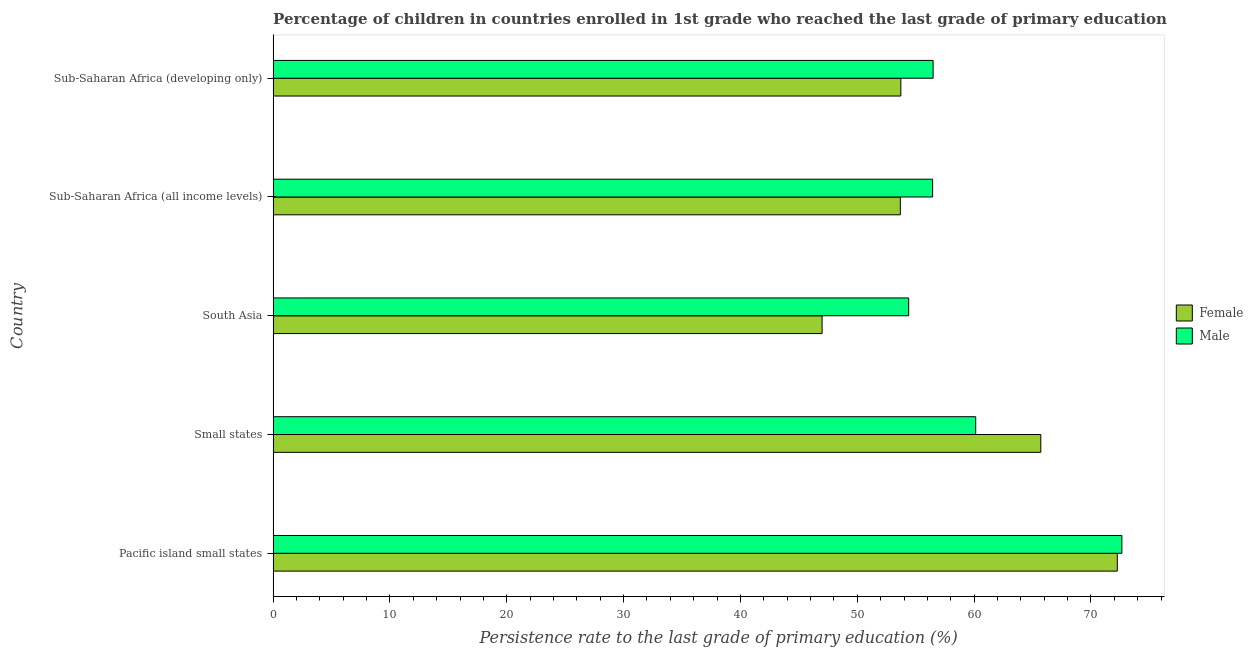How many different coloured bars are there?
Give a very brief answer. 2. Are the number of bars on each tick of the Y-axis equal?
Your response must be concise. Yes. How many bars are there on the 4th tick from the top?
Provide a succinct answer. 2. How many bars are there on the 2nd tick from the bottom?
Give a very brief answer. 2. What is the label of the 1st group of bars from the top?
Your answer should be very brief. Sub-Saharan Africa (developing only). What is the persistence rate of female students in Sub-Saharan Africa (all income levels)?
Make the answer very short. 53.69. Across all countries, what is the maximum persistence rate of female students?
Give a very brief answer. 72.26. Across all countries, what is the minimum persistence rate of male students?
Your response must be concise. 54.4. In which country was the persistence rate of male students maximum?
Offer a very short reply. Pacific island small states. In which country was the persistence rate of female students minimum?
Provide a succinct answer. South Asia. What is the total persistence rate of male students in the graph?
Your answer should be compact. 300.13. What is the difference between the persistence rate of male students in Pacific island small states and that in Sub-Saharan Africa (developing only)?
Ensure brevity in your answer.  16.16. What is the difference between the persistence rate of female students in Sub-Saharan Africa (all income levels) and the persistence rate of male students in Sub-Saharan Africa (developing only)?
Give a very brief answer. -2.81. What is the average persistence rate of female students per country?
Offer a very short reply. 58.48. What is the difference between the persistence rate of female students and persistence rate of male students in Pacific island small states?
Provide a succinct answer. -0.39. Is the persistence rate of female students in Small states less than that in South Asia?
Give a very brief answer. No. Is the difference between the persistence rate of female students in Sub-Saharan Africa (all income levels) and Sub-Saharan Africa (developing only) greater than the difference between the persistence rate of male students in Sub-Saharan Africa (all income levels) and Sub-Saharan Africa (developing only)?
Offer a very short reply. No. What is the difference between the highest and the second highest persistence rate of male students?
Your response must be concise. 12.51. What is the difference between the highest and the lowest persistence rate of female students?
Give a very brief answer. 25.27. Is the sum of the persistence rate of female students in Small states and South Asia greater than the maximum persistence rate of male students across all countries?
Keep it short and to the point. Yes. How many bars are there?
Give a very brief answer. 10. Are all the bars in the graph horizontal?
Offer a terse response. Yes. How many countries are there in the graph?
Offer a terse response. 5. Are the values on the major ticks of X-axis written in scientific E-notation?
Your response must be concise. No. Does the graph contain grids?
Keep it short and to the point. No. How many legend labels are there?
Give a very brief answer. 2. How are the legend labels stacked?
Make the answer very short. Vertical. What is the title of the graph?
Provide a succinct answer. Percentage of children in countries enrolled in 1st grade who reached the last grade of primary education. Does "Total Population" appear as one of the legend labels in the graph?
Offer a very short reply. No. What is the label or title of the X-axis?
Make the answer very short. Persistence rate to the last grade of primary education (%). What is the Persistence rate to the last grade of primary education (%) in Female in Pacific island small states?
Provide a succinct answer. 72.26. What is the Persistence rate to the last grade of primary education (%) in Male in Pacific island small states?
Give a very brief answer. 72.65. What is the Persistence rate to the last grade of primary education (%) of Female in Small states?
Make the answer very short. 65.71. What is the Persistence rate to the last grade of primary education (%) of Male in Small states?
Give a very brief answer. 60.14. What is the Persistence rate to the last grade of primary education (%) of Female in South Asia?
Your response must be concise. 46.99. What is the Persistence rate to the last grade of primary education (%) in Male in South Asia?
Offer a terse response. 54.4. What is the Persistence rate to the last grade of primary education (%) of Female in Sub-Saharan Africa (all income levels)?
Provide a succinct answer. 53.69. What is the Persistence rate to the last grade of primary education (%) in Male in Sub-Saharan Africa (all income levels)?
Keep it short and to the point. 56.45. What is the Persistence rate to the last grade of primary education (%) of Female in Sub-Saharan Africa (developing only)?
Offer a terse response. 53.73. What is the Persistence rate to the last grade of primary education (%) of Male in Sub-Saharan Africa (developing only)?
Your answer should be compact. 56.49. Across all countries, what is the maximum Persistence rate to the last grade of primary education (%) in Female?
Offer a very short reply. 72.26. Across all countries, what is the maximum Persistence rate to the last grade of primary education (%) of Male?
Provide a short and direct response. 72.65. Across all countries, what is the minimum Persistence rate to the last grade of primary education (%) of Female?
Offer a terse response. 46.99. Across all countries, what is the minimum Persistence rate to the last grade of primary education (%) in Male?
Give a very brief answer. 54.4. What is the total Persistence rate to the last grade of primary education (%) of Female in the graph?
Your response must be concise. 292.38. What is the total Persistence rate to the last grade of primary education (%) in Male in the graph?
Provide a succinct answer. 300.13. What is the difference between the Persistence rate to the last grade of primary education (%) in Female in Pacific island small states and that in Small states?
Your answer should be very brief. 6.55. What is the difference between the Persistence rate to the last grade of primary education (%) of Male in Pacific island small states and that in Small states?
Your answer should be very brief. 12.51. What is the difference between the Persistence rate to the last grade of primary education (%) in Female in Pacific island small states and that in South Asia?
Make the answer very short. 25.27. What is the difference between the Persistence rate to the last grade of primary education (%) in Male in Pacific island small states and that in South Asia?
Offer a very short reply. 18.25. What is the difference between the Persistence rate to the last grade of primary education (%) in Female in Pacific island small states and that in Sub-Saharan Africa (all income levels)?
Ensure brevity in your answer.  18.57. What is the difference between the Persistence rate to the last grade of primary education (%) of Male in Pacific island small states and that in Sub-Saharan Africa (all income levels)?
Your answer should be compact. 16.2. What is the difference between the Persistence rate to the last grade of primary education (%) of Female in Pacific island small states and that in Sub-Saharan Africa (developing only)?
Offer a very short reply. 18.53. What is the difference between the Persistence rate to the last grade of primary education (%) in Male in Pacific island small states and that in Sub-Saharan Africa (developing only)?
Ensure brevity in your answer.  16.16. What is the difference between the Persistence rate to the last grade of primary education (%) in Female in Small states and that in South Asia?
Your answer should be compact. 18.72. What is the difference between the Persistence rate to the last grade of primary education (%) in Male in Small states and that in South Asia?
Provide a short and direct response. 5.74. What is the difference between the Persistence rate to the last grade of primary education (%) of Female in Small states and that in Sub-Saharan Africa (all income levels)?
Provide a short and direct response. 12.02. What is the difference between the Persistence rate to the last grade of primary education (%) in Male in Small states and that in Sub-Saharan Africa (all income levels)?
Your answer should be very brief. 3.69. What is the difference between the Persistence rate to the last grade of primary education (%) in Female in Small states and that in Sub-Saharan Africa (developing only)?
Keep it short and to the point. 11.98. What is the difference between the Persistence rate to the last grade of primary education (%) in Male in Small states and that in Sub-Saharan Africa (developing only)?
Offer a terse response. 3.64. What is the difference between the Persistence rate to the last grade of primary education (%) in Female in South Asia and that in Sub-Saharan Africa (all income levels)?
Your answer should be very brief. -6.7. What is the difference between the Persistence rate to the last grade of primary education (%) of Male in South Asia and that in Sub-Saharan Africa (all income levels)?
Make the answer very short. -2.05. What is the difference between the Persistence rate to the last grade of primary education (%) in Female in South Asia and that in Sub-Saharan Africa (developing only)?
Offer a terse response. -6.74. What is the difference between the Persistence rate to the last grade of primary education (%) of Male in South Asia and that in Sub-Saharan Africa (developing only)?
Make the answer very short. -2.09. What is the difference between the Persistence rate to the last grade of primary education (%) in Female in Sub-Saharan Africa (all income levels) and that in Sub-Saharan Africa (developing only)?
Offer a terse response. -0.05. What is the difference between the Persistence rate to the last grade of primary education (%) in Male in Sub-Saharan Africa (all income levels) and that in Sub-Saharan Africa (developing only)?
Offer a very short reply. -0.04. What is the difference between the Persistence rate to the last grade of primary education (%) of Female in Pacific island small states and the Persistence rate to the last grade of primary education (%) of Male in Small states?
Your answer should be very brief. 12.12. What is the difference between the Persistence rate to the last grade of primary education (%) in Female in Pacific island small states and the Persistence rate to the last grade of primary education (%) in Male in South Asia?
Keep it short and to the point. 17.86. What is the difference between the Persistence rate to the last grade of primary education (%) of Female in Pacific island small states and the Persistence rate to the last grade of primary education (%) of Male in Sub-Saharan Africa (all income levels)?
Keep it short and to the point. 15.81. What is the difference between the Persistence rate to the last grade of primary education (%) in Female in Pacific island small states and the Persistence rate to the last grade of primary education (%) in Male in Sub-Saharan Africa (developing only)?
Make the answer very short. 15.76. What is the difference between the Persistence rate to the last grade of primary education (%) of Female in Small states and the Persistence rate to the last grade of primary education (%) of Male in South Asia?
Give a very brief answer. 11.31. What is the difference between the Persistence rate to the last grade of primary education (%) of Female in Small states and the Persistence rate to the last grade of primary education (%) of Male in Sub-Saharan Africa (all income levels)?
Make the answer very short. 9.26. What is the difference between the Persistence rate to the last grade of primary education (%) in Female in Small states and the Persistence rate to the last grade of primary education (%) in Male in Sub-Saharan Africa (developing only)?
Make the answer very short. 9.22. What is the difference between the Persistence rate to the last grade of primary education (%) in Female in South Asia and the Persistence rate to the last grade of primary education (%) in Male in Sub-Saharan Africa (all income levels)?
Offer a terse response. -9.46. What is the difference between the Persistence rate to the last grade of primary education (%) in Female in South Asia and the Persistence rate to the last grade of primary education (%) in Male in Sub-Saharan Africa (developing only)?
Your response must be concise. -9.5. What is the difference between the Persistence rate to the last grade of primary education (%) of Female in Sub-Saharan Africa (all income levels) and the Persistence rate to the last grade of primary education (%) of Male in Sub-Saharan Africa (developing only)?
Keep it short and to the point. -2.81. What is the average Persistence rate to the last grade of primary education (%) in Female per country?
Your answer should be compact. 58.48. What is the average Persistence rate to the last grade of primary education (%) of Male per country?
Your answer should be compact. 60.03. What is the difference between the Persistence rate to the last grade of primary education (%) in Female and Persistence rate to the last grade of primary education (%) in Male in Pacific island small states?
Your answer should be very brief. -0.39. What is the difference between the Persistence rate to the last grade of primary education (%) in Female and Persistence rate to the last grade of primary education (%) in Male in Small states?
Offer a terse response. 5.57. What is the difference between the Persistence rate to the last grade of primary education (%) in Female and Persistence rate to the last grade of primary education (%) in Male in South Asia?
Offer a terse response. -7.41. What is the difference between the Persistence rate to the last grade of primary education (%) of Female and Persistence rate to the last grade of primary education (%) of Male in Sub-Saharan Africa (all income levels)?
Provide a succinct answer. -2.76. What is the difference between the Persistence rate to the last grade of primary education (%) in Female and Persistence rate to the last grade of primary education (%) in Male in Sub-Saharan Africa (developing only)?
Give a very brief answer. -2.76. What is the ratio of the Persistence rate to the last grade of primary education (%) in Female in Pacific island small states to that in Small states?
Your answer should be very brief. 1.1. What is the ratio of the Persistence rate to the last grade of primary education (%) in Male in Pacific island small states to that in Small states?
Give a very brief answer. 1.21. What is the ratio of the Persistence rate to the last grade of primary education (%) in Female in Pacific island small states to that in South Asia?
Your response must be concise. 1.54. What is the ratio of the Persistence rate to the last grade of primary education (%) of Male in Pacific island small states to that in South Asia?
Offer a very short reply. 1.34. What is the ratio of the Persistence rate to the last grade of primary education (%) of Female in Pacific island small states to that in Sub-Saharan Africa (all income levels)?
Provide a short and direct response. 1.35. What is the ratio of the Persistence rate to the last grade of primary education (%) of Male in Pacific island small states to that in Sub-Saharan Africa (all income levels)?
Your response must be concise. 1.29. What is the ratio of the Persistence rate to the last grade of primary education (%) in Female in Pacific island small states to that in Sub-Saharan Africa (developing only)?
Provide a succinct answer. 1.34. What is the ratio of the Persistence rate to the last grade of primary education (%) of Male in Pacific island small states to that in Sub-Saharan Africa (developing only)?
Make the answer very short. 1.29. What is the ratio of the Persistence rate to the last grade of primary education (%) of Female in Small states to that in South Asia?
Keep it short and to the point. 1.4. What is the ratio of the Persistence rate to the last grade of primary education (%) of Male in Small states to that in South Asia?
Make the answer very short. 1.11. What is the ratio of the Persistence rate to the last grade of primary education (%) of Female in Small states to that in Sub-Saharan Africa (all income levels)?
Keep it short and to the point. 1.22. What is the ratio of the Persistence rate to the last grade of primary education (%) of Male in Small states to that in Sub-Saharan Africa (all income levels)?
Ensure brevity in your answer.  1.07. What is the ratio of the Persistence rate to the last grade of primary education (%) in Female in Small states to that in Sub-Saharan Africa (developing only)?
Your answer should be compact. 1.22. What is the ratio of the Persistence rate to the last grade of primary education (%) of Male in Small states to that in Sub-Saharan Africa (developing only)?
Provide a succinct answer. 1.06. What is the ratio of the Persistence rate to the last grade of primary education (%) in Female in South Asia to that in Sub-Saharan Africa (all income levels)?
Offer a very short reply. 0.88. What is the ratio of the Persistence rate to the last grade of primary education (%) of Male in South Asia to that in Sub-Saharan Africa (all income levels)?
Keep it short and to the point. 0.96. What is the ratio of the Persistence rate to the last grade of primary education (%) of Female in South Asia to that in Sub-Saharan Africa (developing only)?
Give a very brief answer. 0.87. What is the ratio of the Persistence rate to the last grade of primary education (%) of Male in South Asia to that in Sub-Saharan Africa (developing only)?
Offer a terse response. 0.96. What is the ratio of the Persistence rate to the last grade of primary education (%) in Female in Sub-Saharan Africa (all income levels) to that in Sub-Saharan Africa (developing only)?
Offer a very short reply. 1. What is the difference between the highest and the second highest Persistence rate to the last grade of primary education (%) of Female?
Your answer should be very brief. 6.55. What is the difference between the highest and the second highest Persistence rate to the last grade of primary education (%) in Male?
Your answer should be very brief. 12.51. What is the difference between the highest and the lowest Persistence rate to the last grade of primary education (%) of Female?
Ensure brevity in your answer.  25.27. What is the difference between the highest and the lowest Persistence rate to the last grade of primary education (%) in Male?
Give a very brief answer. 18.25. 